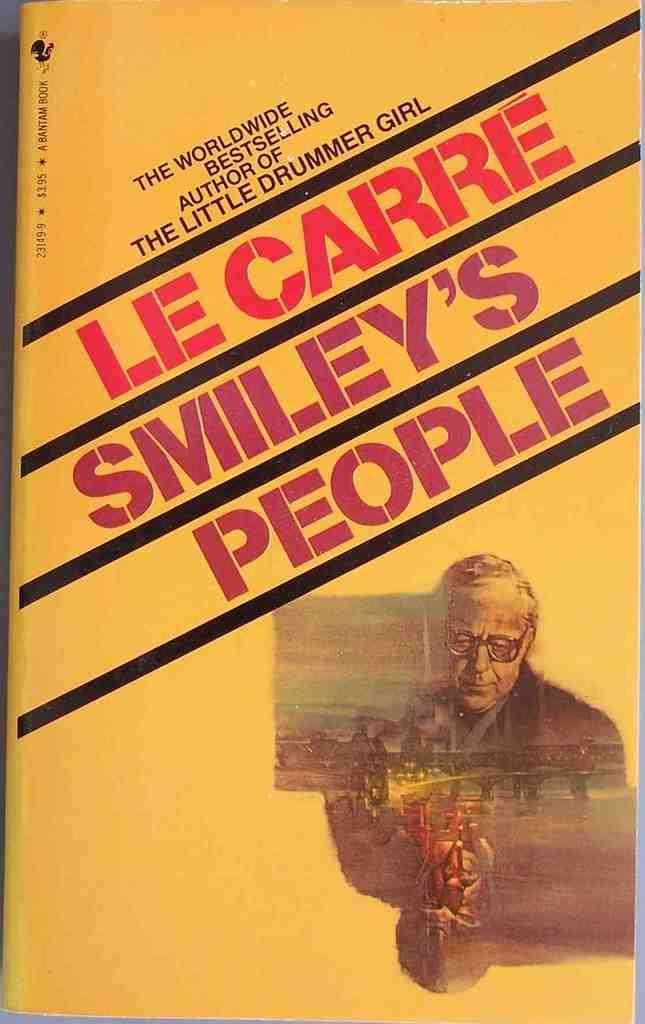<image>
Render a clear and concise summary of the photo. The book Smiley's People by author Le Carre. 